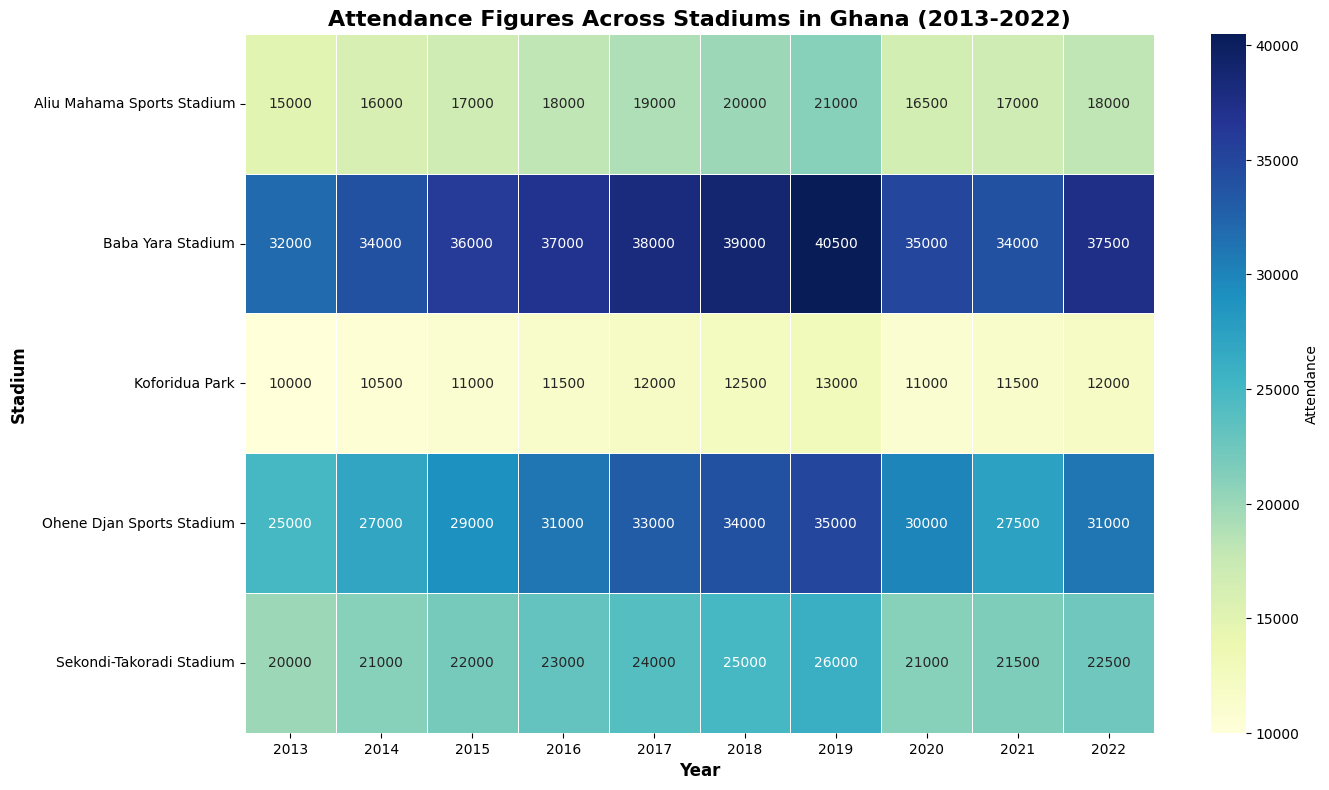What was the highest attendance recorded at Baba Yara Stadium? To find the highest attendance at Baba Yara Stadium, look for the maximum value in the corresponding row in the heatmap. The highest value in the row for Baba Yara Stadium is 40500, recorded in 2019.
Answer: 40500 Which year did the Ohene Djan Sports Stadium see a drop in attendance from the previous year? To identify a drop, compare the attendance values year by year for the Ohene Djan Sports Stadium. The years showing a decrease in attendance compared to the previous year are 2020 and 2021, with significant drops from 35000 to 30000 and from 31000 to 27500 respectively.
Answer: 2020 and 2021 Which stadium had the lowest overall attendance in any given year? Check for the minimum value across the entire heatmap. The lowest attendance recorded is 10000 at Koforidua Park in 2013.
Answer: Koforidua Park in 2013 What is the average attendance at the Sekondi-Takoradi Stadium over the decade? Sum the attendance figures for Sekondi-Takoradi Stadium from 2013 to 2022 and divide by the number of years (10). The total is 227500, and the average is 227500/10 = 22750.
Answer: 22750 Between Greater Accra and Ashanti regions, which had a greater increase in attendance from 2013 to 2019 at their respective main stadiums? Calculate the difference between 2019 and 2013 attendance for Ohene Djan Sports Stadium and Baba Yara Stadium. For Ohene Djan: 35000 - 25000 = 10000. For Baba Yara: 40500 - 32000 = 8500. Greater Accra had a greater increase.
Answer: Greater Accra Which year has the darkest shade of blue across all stadiums, indicating the highest attendance? Look for the darkest shade of blue across the heatmap. The darkest shade and highest attendance is 40500, recorded in 2019 at Baba Yara Stadium.
Answer: 2019 In which year did the Aliu Mahama Sports Stadium see its highest attendance, and what was the value? Check the row for Aliu Mahama Sports Stadium and identify the highest value. The highest attendance was 21000 in the year 2019.
Answer: 2019 and 21000 How does the attendance in 2020 compare across all stadiums? For 2020, check the row values corresponding to 2020 for all stadiums: Ohene Djan (30000), Baba Yara (35000), Sekondi-Takoradi (21000), Aliu Mahama (16500), and Koforidua Park (11000). Baba Yara had the highest attendance, while Koforidua Park had the lowest.
Answer: Baba Yara highest, Koforidua Park lowest Was there any stadium that experienced consecutive years of declining attendance? If so, which one? Compare year-on-year attendance for each stadium. Both Ohene Djan Sports Stadium (2020 and 2021) and Aliu Mahama Sports Stadium (2020 and 2021) had consecutive declines in attendance.
Answer: Ohene Djan and Aliu Mahama Which stadium had the most consistent attendance figures over the decade, and how can you tell? Identify the stadium with the least variation in attendance figures by looking at the color shade uniformity and values. Sekondi-Takoradi Stadium attendance fluctuated minimally around the 20000-26000 range, indicating consistent attendance.
Answer: Sekondi-Takoradi Stadium 